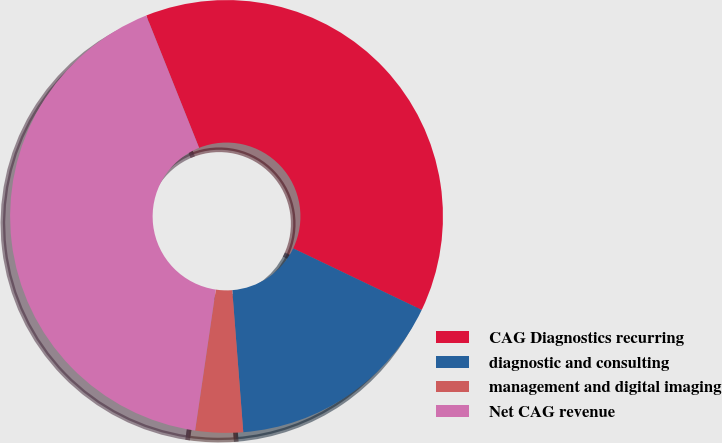Convert chart. <chart><loc_0><loc_0><loc_500><loc_500><pie_chart><fcel>CAG Diagnostics recurring<fcel>diagnostic and consulting<fcel>management and digital imaging<fcel>Net CAG revenue<nl><fcel>38.16%<fcel>16.66%<fcel>3.55%<fcel>41.64%<nl></chart> 